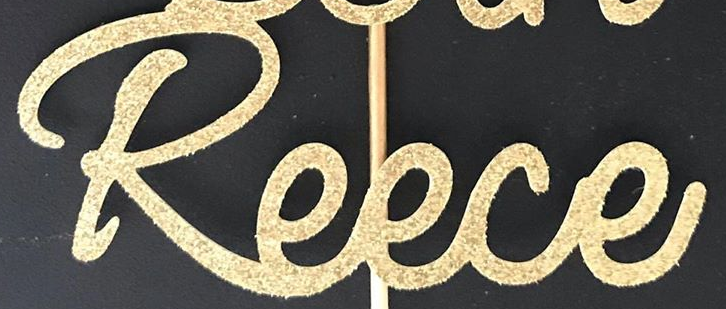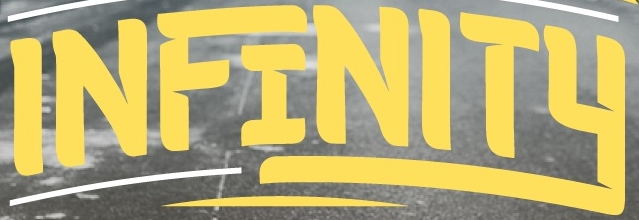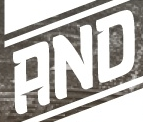What words are shown in these images in order, separated by a semicolon? Reece; INFINITY; AND 